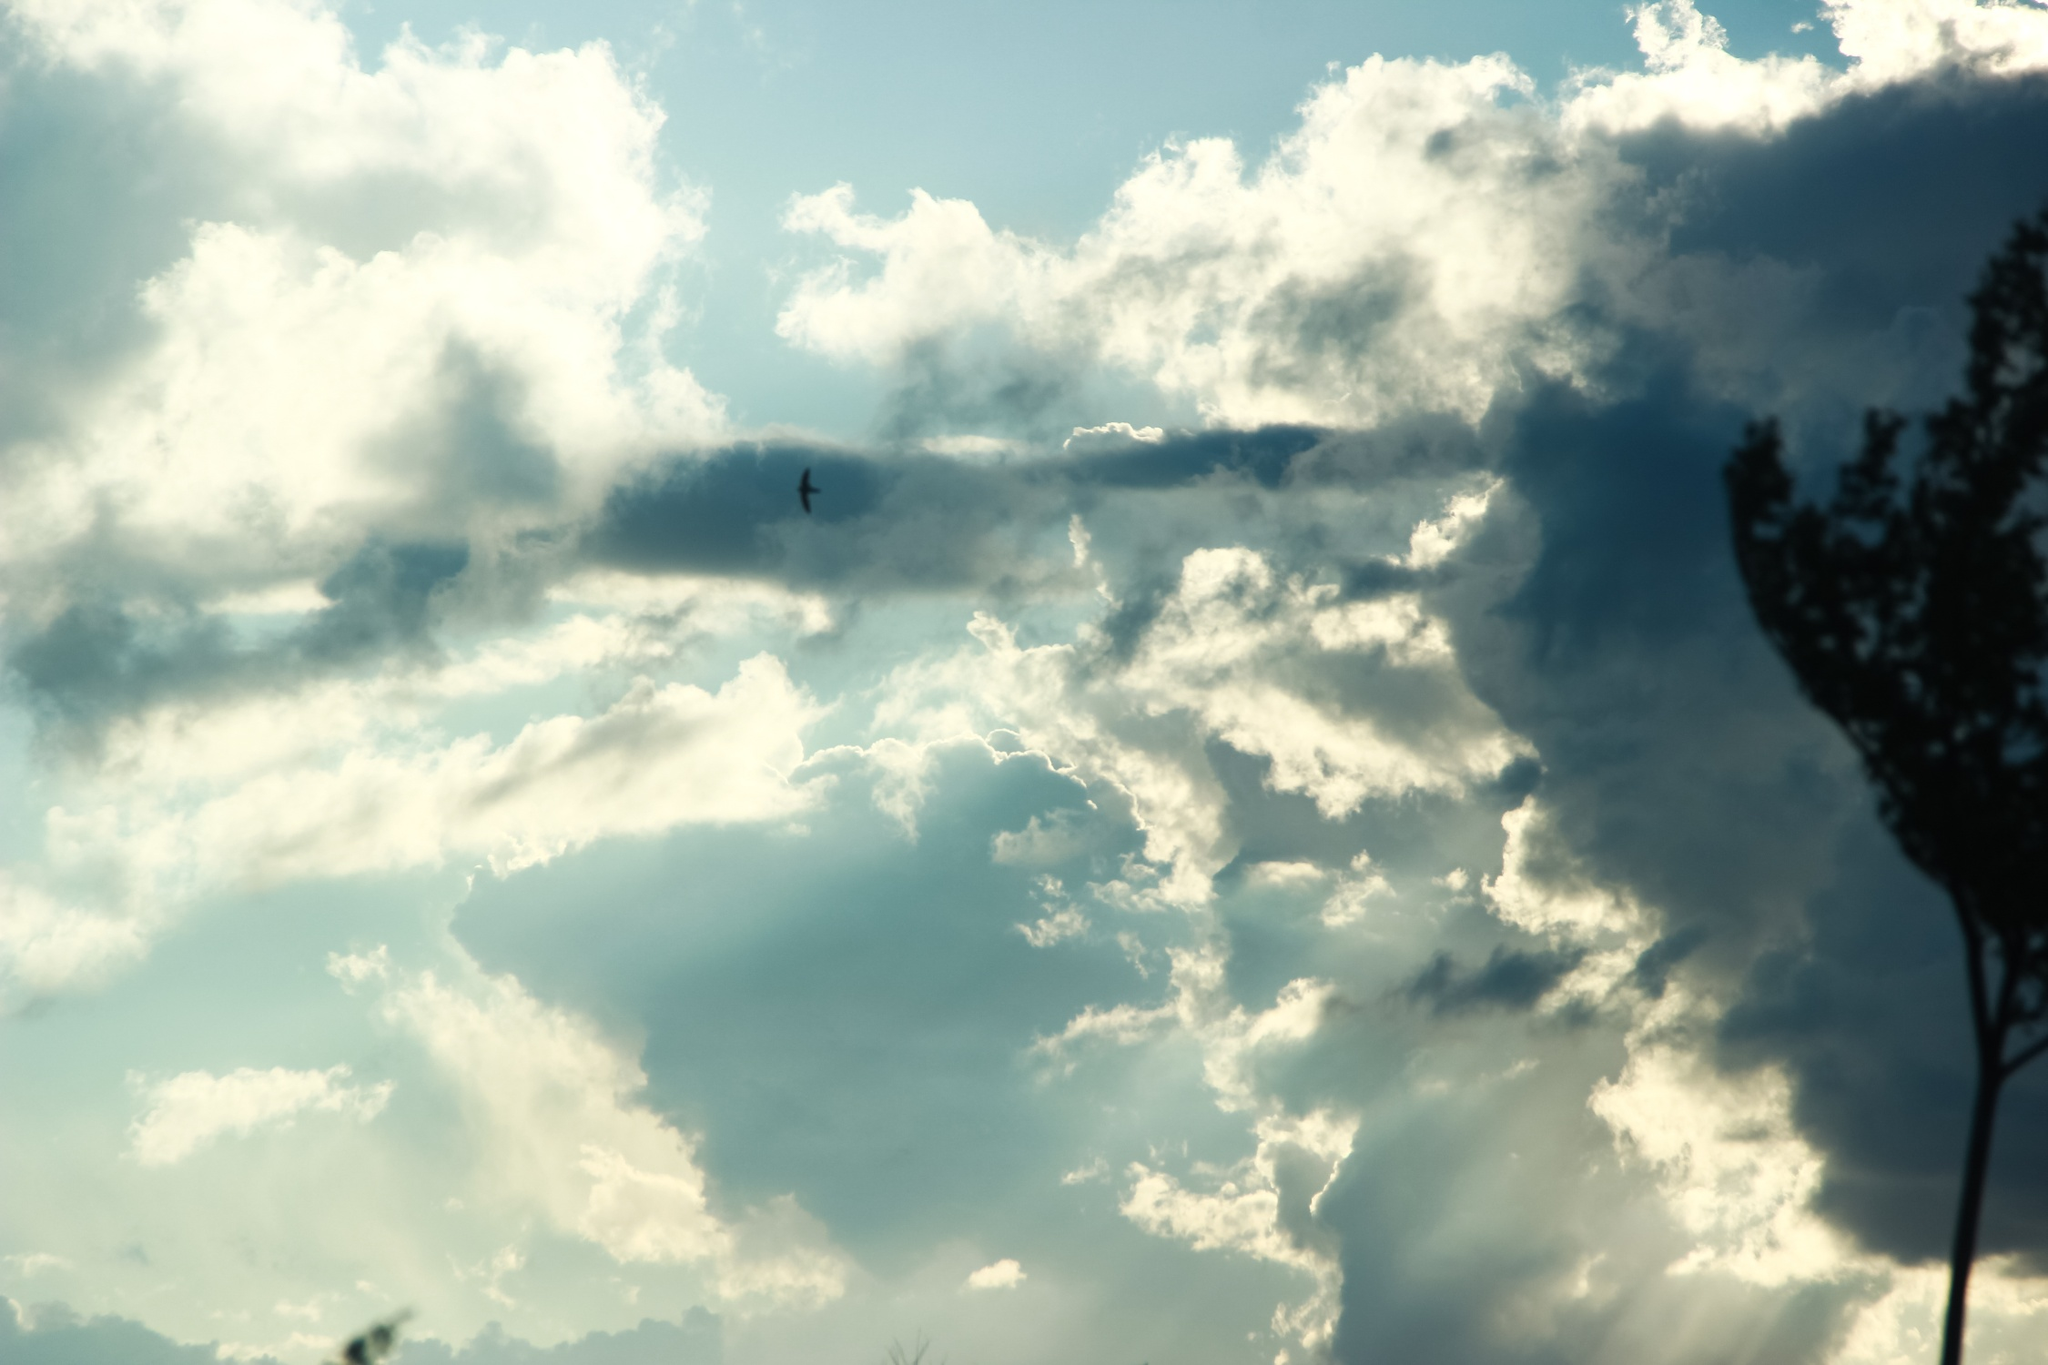Can you describe this scene poetically? In a realm of azure dreams, where skies paint whispers in shades of blue, a lonely tree stands tall—a sentinel reaching with grasping limbs toward infinity. Wisps of clouds drift lazily, weaving tales of ephemeral beauty. A solitary bird, a tiny courier of hope, cuts through the heavens on wings of freedom. Here, amidst nature's embrace, tranquility speaks in soft, breathless murmurs—a tableau where the soul finds its solace, and the heart, its serene rhythm. 